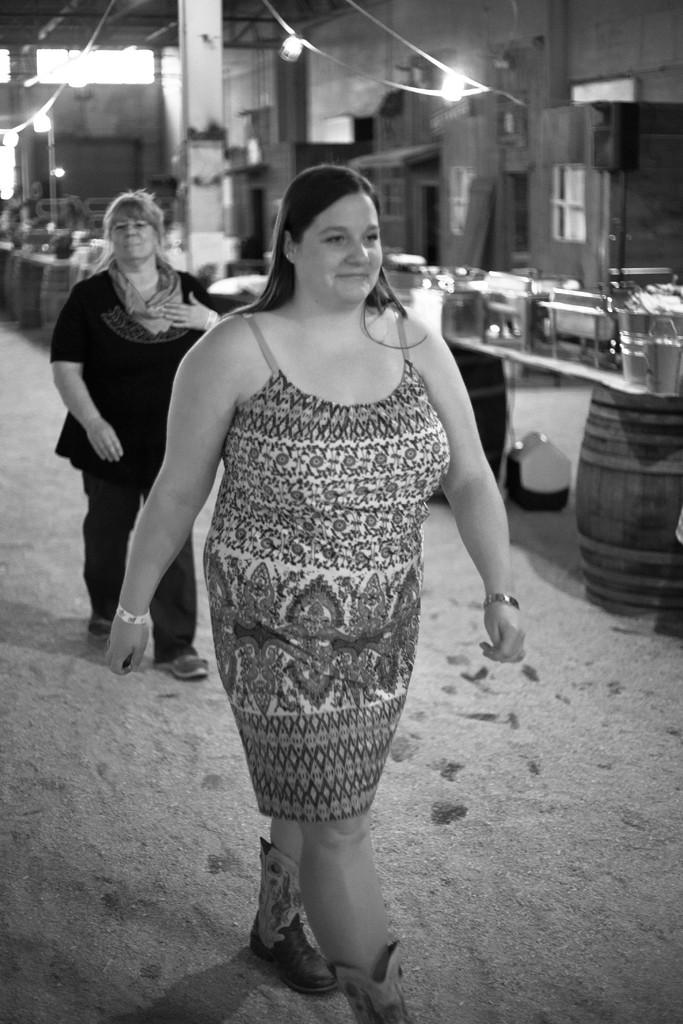What is the color scheme of the image? The image is black and white. What are the two people in the image doing? The two people in the image are walking in the room. What type of objects can be seen in the room? There are barrels visible in the room. Can you describe any other objects present in the room? There are other objects present in the room, but their specific details are not mentioned in the provided facts. How many brothers are present in the image? The provided facts do not mention any brothers, so it is impossible to determine the number of brothers in the image. Is there a cave visible in the image? There is no mention of a cave in the provided facts, so it is not possible to determine if a cave is present in the image. 